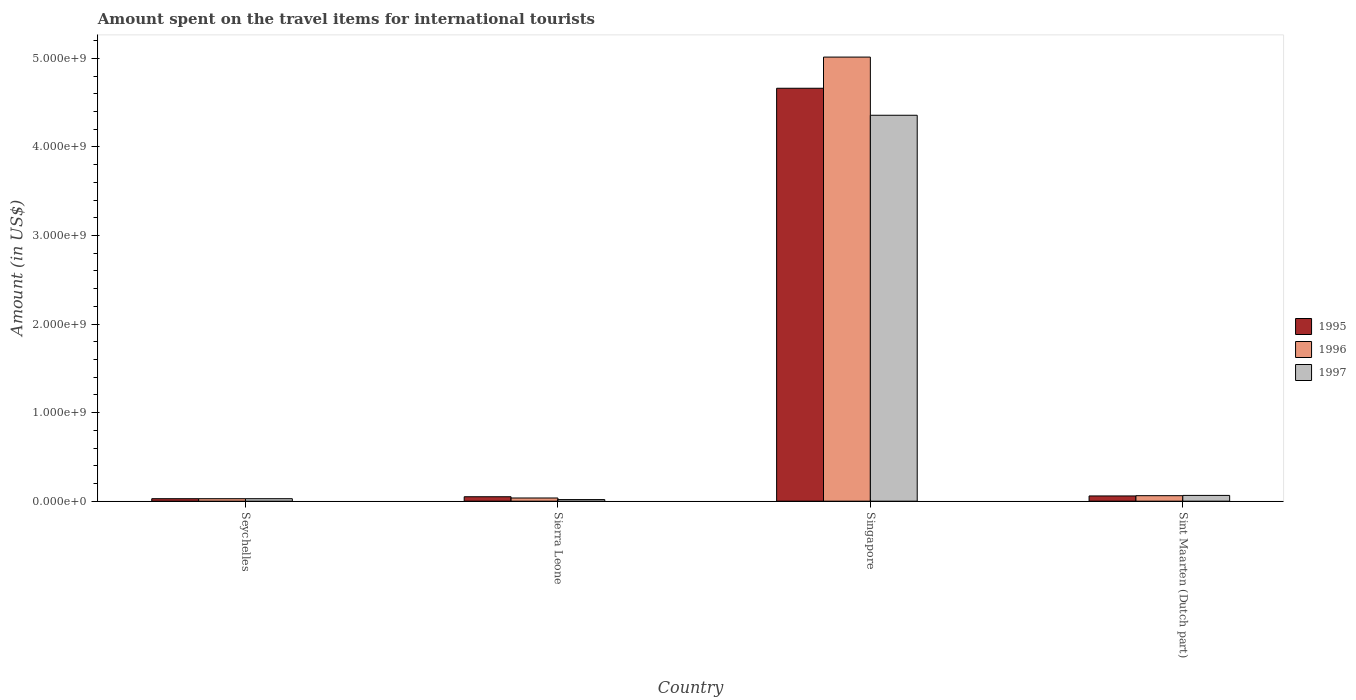How many bars are there on the 3rd tick from the left?
Offer a terse response. 3. What is the label of the 2nd group of bars from the left?
Offer a very short reply. Sierra Leone. What is the amount spent on the travel items for international tourists in 1996 in Sint Maarten (Dutch part)?
Provide a short and direct response. 6.20e+07. Across all countries, what is the maximum amount spent on the travel items for international tourists in 1996?
Offer a terse response. 5.02e+09. Across all countries, what is the minimum amount spent on the travel items for international tourists in 1996?
Keep it short and to the point. 2.80e+07. In which country was the amount spent on the travel items for international tourists in 1995 maximum?
Provide a succinct answer. Singapore. In which country was the amount spent on the travel items for international tourists in 1996 minimum?
Make the answer very short. Seychelles. What is the total amount spent on the travel items for international tourists in 1995 in the graph?
Make the answer very short. 4.80e+09. What is the difference between the amount spent on the travel items for international tourists in 1996 in Sierra Leone and that in Singapore?
Your answer should be very brief. -4.98e+09. What is the difference between the amount spent on the travel items for international tourists in 1997 in Sint Maarten (Dutch part) and the amount spent on the travel items for international tourists in 1995 in Seychelles?
Offer a terse response. 3.70e+07. What is the average amount spent on the travel items for international tourists in 1996 per country?
Your answer should be compact. 1.29e+09. What is the difference between the amount spent on the travel items for international tourists of/in 1995 and amount spent on the travel items for international tourists of/in 1997 in Singapore?
Give a very brief answer. 3.05e+08. In how many countries, is the amount spent on the travel items for international tourists in 1996 greater than 2400000000 US$?
Keep it short and to the point. 1. What is the ratio of the amount spent on the travel items for international tourists in 1997 in Seychelles to that in Sint Maarten (Dutch part)?
Provide a short and direct response. 0.43. What is the difference between the highest and the second highest amount spent on the travel items for international tourists in 1996?
Provide a succinct answer. 4.98e+09. What is the difference between the highest and the lowest amount spent on the travel items for international tourists in 1997?
Ensure brevity in your answer.  4.34e+09. In how many countries, is the amount spent on the travel items for international tourists in 1997 greater than the average amount spent on the travel items for international tourists in 1997 taken over all countries?
Your response must be concise. 1. Is the sum of the amount spent on the travel items for international tourists in 1997 in Seychelles and Singapore greater than the maximum amount spent on the travel items for international tourists in 1995 across all countries?
Keep it short and to the point. No. What does the 1st bar from the right in Sint Maarten (Dutch part) represents?
Offer a very short reply. 1997. Is it the case that in every country, the sum of the amount spent on the travel items for international tourists in 1997 and amount spent on the travel items for international tourists in 1995 is greater than the amount spent on the travel items for international tourists in 1996?
Your response must be concise. Yes. Are all the bars in the graph horizontal?
Offer a very short reply. No. How many countries are there in the graph?
Offer a terse response. 4. Does the graph contain grids?
Give a very brief answer. No. Where does the legend appear in the graph?
Give a very brief answer. Center right. How many legend labels are there?
Give a very brief answer. 3. How are the legend labels stacked?
Provide a short and direct response. Vertical. What is the title of the graph?
Your answer should be very brief. Amount spent on the travel items for international tourists. Does "1974" appear as one of the legend labels in the graph?
Offer a terse response. No. What is the label or title of the Y-axis?
Make the answer very short. Amount (in US$). What is the Amount (in US$) in 1995 in Seychelles?
Ensure brevity in your answer.  2.80e+07. What is the Amount (in US$) in 1996 in Seychelles?
Provide a short and direct response. 2.80e+07. What is the Amount (in US$) of 1997 in Seychelles?
Give a very brief answer. 2.80e+07. What is the Amount (in US$) in 1995 in Sierra Leone?
Your answer should be compact. 5.00e+07. What is the Amount (in US$) in 1996 in Sierra Leone?
Ensure brevity in your answer.  3.60e+07. What is the Amount (in US$) in 1997 in Sierra Leone?
Provide a succinct answer. 1.80e+07. What is the Amount (in US$) in 1995 in Singapore?
Your response must be concise. 4.66e+09. What is the Amount (in US$) in 1996 in Singapore?
Provide a succinct answer. 5.02e+09. What is the Amount (in US$) in 1997 in Singapore?
Give a very brief answer. 4.36e+09. What is the Amount (in US$) of 1995 in Sint Maarten (Dutch part)?
Make the answer very short. 5.90e+07. What is the Amount (in US$) of 1996 in Sint Maarten (Dutch part)?
Your answer should be compact. 6.20e+07. What is the Amount (in US$) in 1997 in Sint Maarten (Dutch part)?
Make the answer very short. 6.50e+07. Across all countries, what is the maximum Amount (in US$) of 1995?
Offer a terse response. 4.66e+09. Across all countries, what is the maximum Amount (in US$) of 1996?
Your response must be concise. 5.02e+09. Across all countries, what is the maximum Amount (in US$) in 1997?
Your response must be concise. 4.36e+09. Across all countries, what is the minimum Amount (in US$) in 1995?
Make the answer very short. 2.80e+07. Across all countries, what is the minimum Amount (in US$) in 1996?
Ensure brevity in your answer.  2.80e+07. Across all countries, what is the minimum Amount (in US$) of 1997?
Your answer should be compact. 1.80e+07. What is the total Amount (in US$) of 1995 in the graph?
Make the answer very short. 4.80e+09. What is the total Amount (in US$) of 1996 in the graph?
Offer a terse response. 5.14e+09. What is the total Amount (in US$) in 1997 in the graph?
Your answer should be very brief. 4.47e+09. What is the difference between the Amount (in US$) in 1995 in Seychelles and that in Sierra Leone?
Offer a very short reply. -2.20e+07. What is the difference between the Amount (in US$) in 1996 in Seychelles and that in Sierra Leone?
Your answer should be compact. -8.00e+06. What is the difference between the Amount (in US$) in 1997 in Seychelles and that in Sierra Leone?
Make the answer very short. 1.00e+07. What is the difference between the Amount (in US$) in 1995 in Seychelles and that in Singapore?
Your answer should be very brief. -4.64e+09. What is the difference between the Amount (in US$) in 1996 in Seychelles and that in Singapore?
Make the answer very short. -4.99e+09. What is the difference between the Amount (in US$) in 1997 in Seychelles and that in Singapore?
Your answer should be very brief. -4.33e+09. What is the difference between the Amount (in US$) of 1995 in Seychelles and that in Sint Maarten (Dutch part)?
Offer a terse response. -3.10e+07. What is the difference between the Amount (in US$) in 1996 in Seychelles and that in Sint Maarten (Dutch part)?
Provide a succinct answer. -3.40e+07. What is the difference between the Amount (in US$) of 1997 in Seychelles and that in Sint Maarten (Dutch part)?
Your answer should be compact. -3.70e+07. What is the difference between the Amount (in US$) of 1995 in Sierra Leone and that in Singapore?
Make the answer very short. -4.61e+09. What is the difference between the Amount (in US$) of 1996 in Sierra Leone and that in Singapore?
Offer a very short reply. -4.98e+09. What is the difference between the Amount (in US$) of 1997 in Sierra Leone and that in Singapore?
Ensure brevity in your answer.  -4.34e+09. What is the difference between the Amount (in US$) of 1995 in Sierra Leone and that in Sint Maarten (Dutch part)?
Provide a short and direct response. -9.00e+06. What is the difference between the Amount (in US$) of 1996 in Sierra Leone and that in Sint Maarten (Dutch part)?
Your response must be concise. -2.60e+07. What is the difference between the Amount (in US$) in 1997 in Sierra Leone and that in Sint Maarten (Dutch part)?
Give a very brief answer. -4.70e+07. What is the difference between the Amount (in US$) in 1995 in Singapore and that in Sint Maarten (Dutch part)?
Provide a succinct answer. 4.60e+09. What is the difference between the Amount (in US$) of 1996 in Singapore and that in Sint Maarten (Dutch part)?
Provide a short and direct response. 4.95e+09. What is the difference between the Amount (in US$) in 1997 in Singapore and that in Sint Maarten (Dutch part)?
Ensure brevity in your answer.  4.29e+09. What is the difference between the Amount (in US$) of 1995 in Seychelles and the Amount (in US$) of 1996 in Sierra Leone?
Offer a very short reply. -8.00e+06. What is the difference between the Amount (in US$) in 1995 in Seychelles and the Amount (in US$) in 1997 in Sierra Leone?
Ensure brevity in your answer.  1.00e+07. What is the difference between the Amount (in US$) in 1995 in Seychelles and the Amount (in US$) in 1996 in Singapore?
Your answer should be compact. -4.99e+09. What is the difference between the Amount (in US$) in 1995 in Seychelles and the Amount (in US$) in 1997 in Singapore?
Provide a succinct answer. -4.33e+09. What is the difference between the Amount (in US$) of 1996 in Seychelles and the Amount (in US$) of 1997 in Singapore?
Keep it short and to the point. -4.33e+09. What is the difference between the Amount (in US$) of 1995 in Seychelles and the Amount (in US$) of 1996 in Sint Maarten (Dutch part)?
Your answer should be compact. -3.40e+07. What is the difference between the Amount (in US$) of 1995 in Seychelles and the Amount (in US$) of 1997 in Sint Maarten (Dutch part)?
Offer a very short reply. -3.70e+07. What is the difference between the Amount (in US$) of 1996 in Seychelles and the Amount (in US$) of 1997 in Sint Maarten (Dutch part)?
Your answer should be very brief. -3.70e+07. What is the difference between the Amount (in US$) of 1995 in Sierra Leone and the Amount (in US$) of 1996 in Singapore?
Your answer should be compact. -4.96e+09. What is the difference between the Amount (in US$) in 1995 in Sierra Leone and the Amount (in US$) in 1997 in Singapore?
Your response must be concise. -4.31e+09. What is the difference between the Amount (in US$) in 1996 in Sierra Leone and the Amount (in US$) in 1997 in Singapore?
Your answer should be very brief. -4.32e+09. What is the difference between the Amount (in US$) of 1995 in Sierra Leone and the Amount (in US$) of 1996 in Sint Maarten (Dutch part)?
Your answer should be very brief. -1.20e+07. What is the difference between the Amount (in US$) in 1995 in Sierra Leone and the Amount (in US$) in 1997 in Sint Maarten (Dutch part)?
Offer a very short reply. -1.50e+07. What is the difference between the Amount (in US$) of 1996 in Sierra Leone and the Amount (in US$) of 1997 in Sint Maarten (Dutch part)?
Your answer should be compact. -2.90e+07. What is the difference between the Amount (in US$) of 1995 in Singapore and the Amount (in US$) of 1996 in Sint Maarten (Dutch part)?
Your answer should be very brief. 4.60e+09. What is the difference between the Amount (in US$) of 1995 in Singapore and the Amount (in US$) of 1997 in Sint Maarten (Dutch part)?
Ensure brevity in your answer.  4.60e+09. What is the difference between the Amount (in US$) of 1996 in Singapore and the Amount (in US$) of 1997 in Sint Maarten (Dutch part)?
Offer a very short reply. 4.95e+09. What is the average Amount (in US$) of 1995 per country?
Your answer should be compact. 1.20e+09. What is the average Amount (in US$) of 1996 per country?
Provide a succinct answer. 1.29e+09. What is the average Amount (in US$) of 1997 per country?
Your answer should be compact. 1.12e+09. What is the difference between the Amount (in US$) of 1995 and Amount (in US$) of 1997 in Seychelles?
Keep it short and to the point. 0. What is the difference between the Amount (in US$) in 1996 and Amount (in US$) in 1997 in Seychelles?
Make the answer very short. 0. What is the difference between the Amount (in US$) of 1995 and Amount (in US$) of 1996 in Sierra Leone?
Provide a short and direct response. 1.40e+07. What is the difference between the Amount (in US$) of 1995 and Amount (in US$) of 1997 in Sierra Leone?
Make the answer very short. 3.20e+07. What is the difference between the Amount (in US$) of 1996 and Amount (in US$) of 1997 in Sierra Leone?
Offer a terse response. 1.80e+07. What is the difference between the Amount (in US$) in 1995 and Amount (in US$) in 1996 in Singapore?
Ensure brevity in your answer.  -3.52e+08. What is the difference between the Amount (in US$) of 1995 and Amount (in US$) of 1997 in Singapore?
Provide a short and direct response. 3.05e+08. What is the difference between the Amount (in US$) in 1996 and Amount (in US$) in 1997 in Singapore?
Your answer should be very brief. 6.57e+08. What is the difference between the Amount (in US$) in 1995 and Amount (in US$) in 1997 in Sint Maarten (Dutch part)?
Offer a terse response. -6.00e+06. What is the ratio of the Amount (in US$) of 1995 in Seychelles to that in Sierra Leone?
Provide a short and direct response. 0.56. What is the ratio of the Amount (in US$) in 1996 in Seychelles to that in Sierra Leone?
Provide a succinct answer. 0.78. What is the ratio of the Amount (in US$) in 1997 in Seychelles to that in Sierra Leone?
Your response must be concise. 1.56. What is the ratio of the Amount (in US$) of 1995 in Seychelles to that in Singapore?
Offer a very short reply. 0.01. What is the ratio of the Amount (in US$) in 1996 in Seychelles to that in Singapore?
Your answer should be compact. 0.01. What is the ratio of the Amount (in US$) in 1997 in Seychelles to that in Singapore?
Your answer should be compact. 0.01. What is the ratio of the Amount (in US$) in 1995 in Seychelles to that in Sint Maarten (Dutch part)?
Make the answer very short. 0.47. What is the ratio of the Amount (in US$) in 1996 in Seychelles to that in Sint Maarten (Dutch part)?
Your response must be concise. 0.45. What is the ratio of the Amount (in US$) in 1997 in Seychelles to that in Sint Maarten (Dutch part)?
Your answer should be compact. 0.43. What is the ratio of the Amount (in US$) in 1995 in Sierra Leone to that in Singapore?
Keep it short and to the point. 0.01. What is the ratio of the Amount (in US$) of 1996 in Sierra Leone to that in Singapore?
Your response must be concise. 0.01. What is the ratio of the Amount (in US$) of 1997 in Sierra Leone to that in Singapore?
Provide a succinct answer. 0. What is the ratio of the Amount (in US$) in 1995 in Sierra Leone to that in Sint Maarten (Dutch part)?
Provide a succinct answer. 0.85. What is the ratio of the Amount (in US$) in 1996 in Sierra Leone to that in Sint Maarten (Dutch part)?
Offer a terse response. 0.58. What is the ratio of the Amount (in US$) in 1997 in Sierra Leone to that in Sint Maarten (Dutch part)?
Keep it short and to the point. 0.28. What is the ratio of the Amount (in US$) in 1995 in Singapore to that in Sint Maarten (Dutch part)?
Make the answer very short. 79.03. What is the ratio of the Amount (in US$) in 1996 in Singapore to that in Sint Maarten (Dutch part)?
Provide a succinct answer. 80.89. What is the ratio of the Amount (in US$) of 1997 in Singapore to that in Sint Maarten (Dutch part)?
Offer a very short reply. 67.05. What is the difference between the highest and the second highest Amount (in US$) in 1995?
Your response must be concise. 4.60e+09. What is the difference between the highest and the second highest Amount (in US$) of 1996?
Your response must be concise. 4.95e+09. What is the difference between the highest and the second highest Amount (in US$) of 1997?
Your response must be concise. 4.29e+09. What is the difference between the highest and the lowest Amount (in US$) of 1995?
Ensure brevity in your answer.  4.64e+09. What is the difference between the highest and the lowest Amount (in US$) of 1996?
Ensure brevity in your answer.  4.99e+09. What is the difference between the highest and the lowest Amount (in US$) in 1997?
Ensure brevity in your answer.  4.34e+09. 